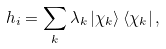Convert formula to latex. <formula><loc_0><loc_0><loc_500><loc_500>h _ { i } = \sum _ { k } \lambda _ { k } \left | \chi _ { k } \right \rangle \left \langle \chi _ { k } \right | ,</formula> 